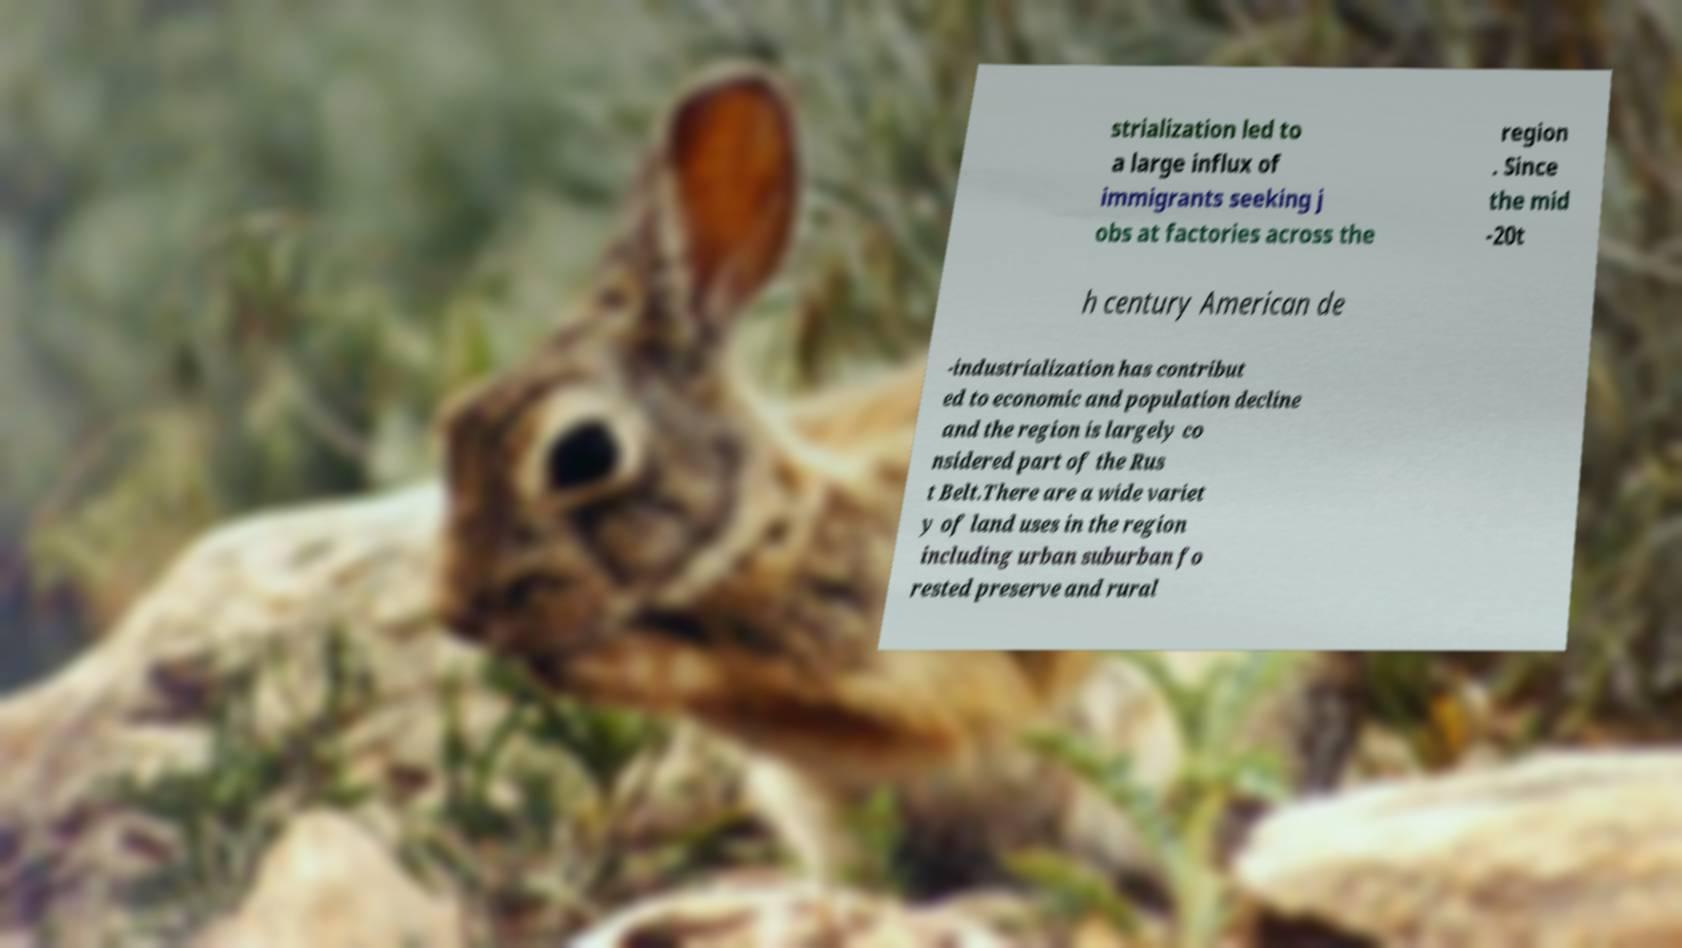There's text embedded in this image that I need extracted. Can you transcribe it verbatim? strialization led to a large influx of immigrants seeking j obs at factories across the region . Since the mid -20t h century American de -industrialization has contribut ed to economic and population decline and the region is largely co nsidered part of the Rus t Belt.There are a wide variet y of land uses in the region including urban suburban fo rested preserve and rural 